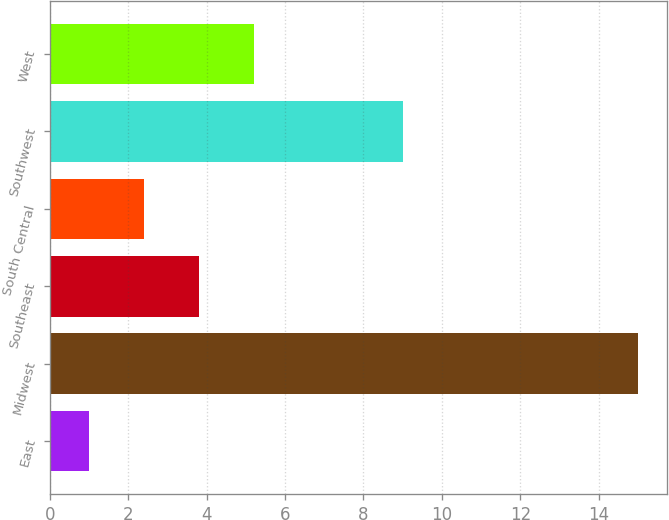Convert chart to OTSL. <chart><loc_0><loc_0><loc_500><loc_500><bar_chart><fcel>East<fcel>Midwest<fcel>Southeast<fcel>South Central<fcel>Southwest<fcel>West<nl><fcel>1<fcel>15<fcel>3.8<fcel>2.4<fcel>9<fcel>5.2<nl></chart> 